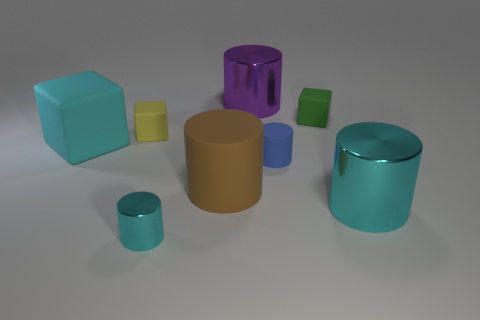How many cyan cylinders must be subtracted to get 1 cyan cylinders? 1 Subtract all shiny cylinders. How many cylinders are left? 2 Subtract all purple spheres. How many cyan cylinders are left? 2 Add 1 large cyan blocks. How many objects exist? 9 Subtract all brown cylinders. How many cylinders are left? 4 Subtract 5 cylinders. How many cylinders are left? 0 Subtract all big cyan metal objects. Subtract all small red cubes. How many objects are left? 7 Add 5 purple shiny cylinders. How many purple shiny cylinders are left? 6 Add 2 big purple objects. How many big purple objects exist? 3 Subtract 1 yellow blocks. How many objects are left? 7 